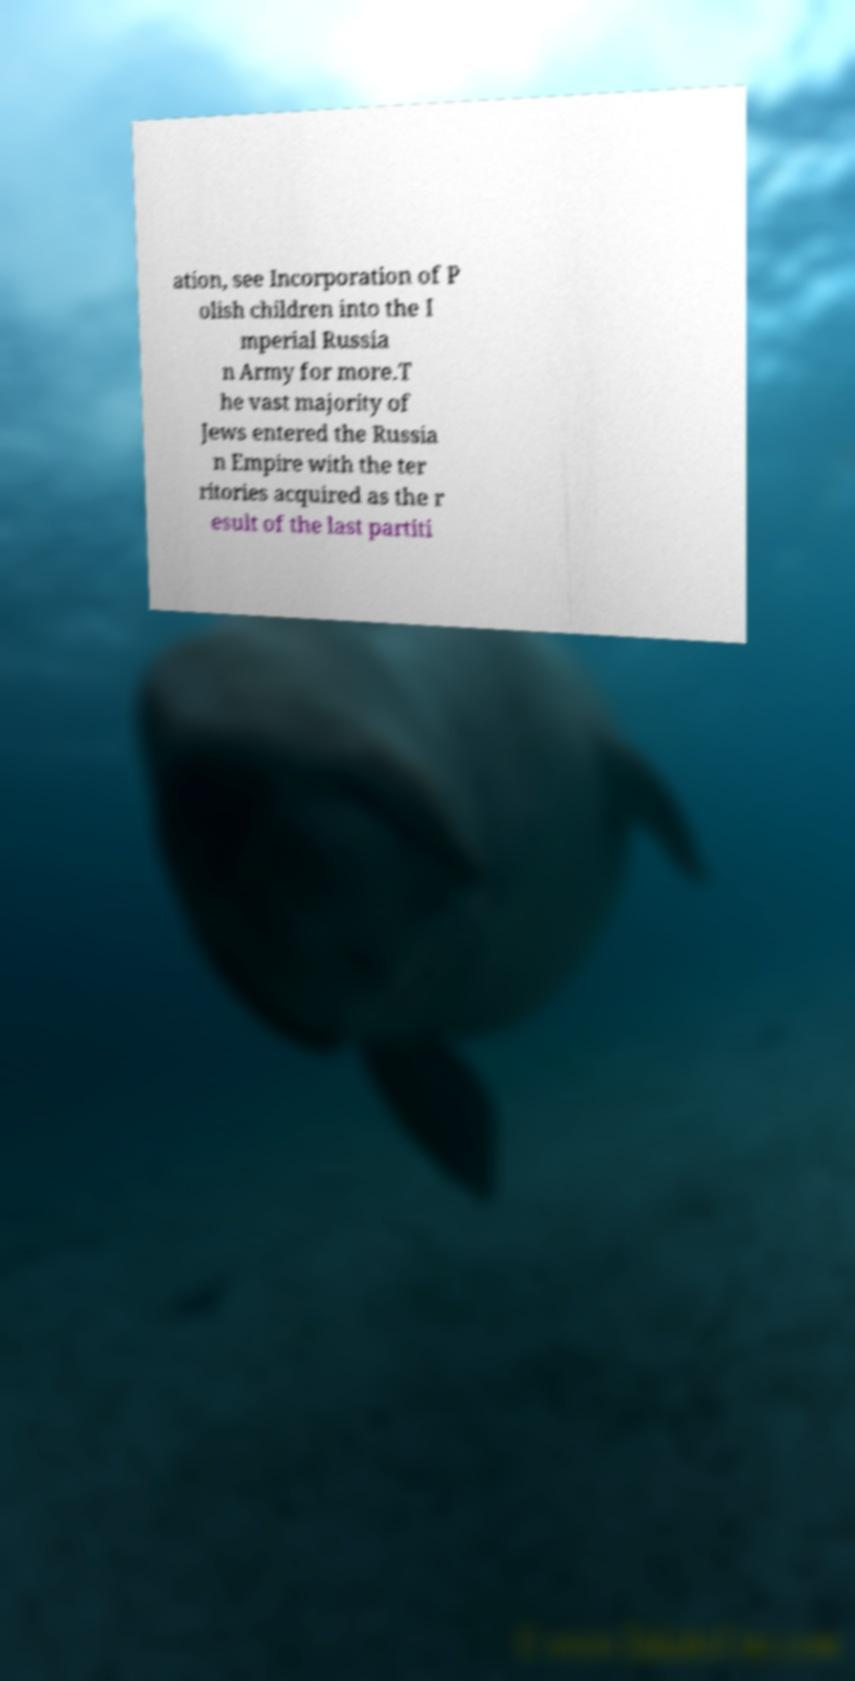I need the written content from this picture converted into text. Can you do that? ation, see Incorporation of P olish children into the I mperial Russia n Army for more.T he vast majority of Jews entered the Russia n Empire with the ter ritories acquired as the r esult of the last partiti 